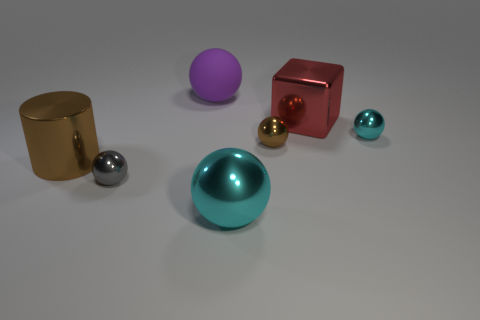How many other objects are there of the same material as the block?
Make the answer very short. 5. There is a gray shiny thing that is the same shape as the purple object; what is its size?
Offer a terse response. Small. Is the color of the big metal block the same as the metal cylinder?
Your answer should be very brief. No. What is the color of the thing that is both to the left of the red thing and behind the tiny cyan metal thing?
Ensure brevity in your answer.  Purple. What number of things are either small shiny objects behind the big cylinder or big red metallic cubes?
Make the answer very short. 3. The matte thing that is the same shape as the tiny brown metallic thing is what color?
Your answer should be very brief. Purple. There is a big cyan shiny object; is its shape the same as the big metallic object on the right side of the large cyan metallic sphere?
Offer a very short reply. No. How many things are either purple rubber things that are to the left of the small brown metallic object or small things on the left side of the large matte object?
Your answer should be compact. 2. Are there fewer cyan objects that are in front of the brown cylinder than red rubber cubes?
Your answer should be very brief. No. Does the purple sphere have the same material as the small object in front of the tiny brown metallic sphere?
Ensure brevity in your answer.  No. 